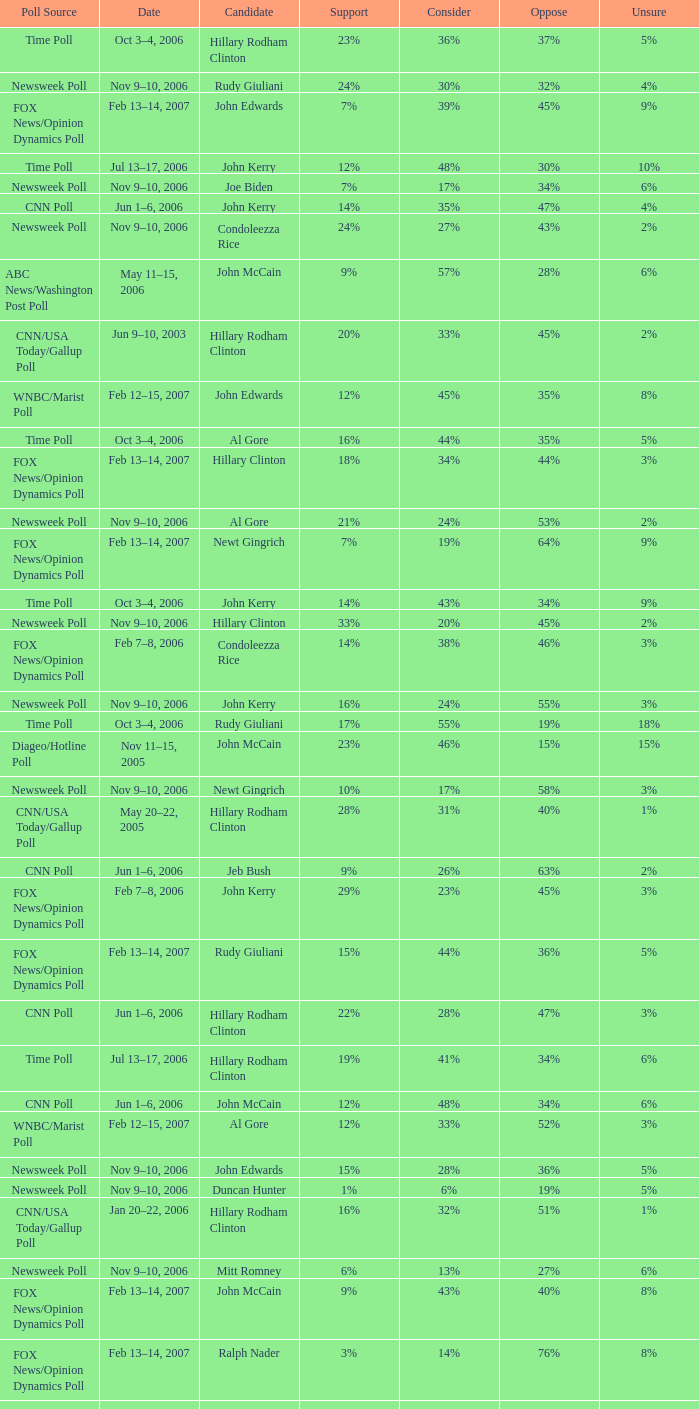What percentage of people were opposed to the candidate based on the Time Poll poll that showed 6% of people were unsure? 34%. 